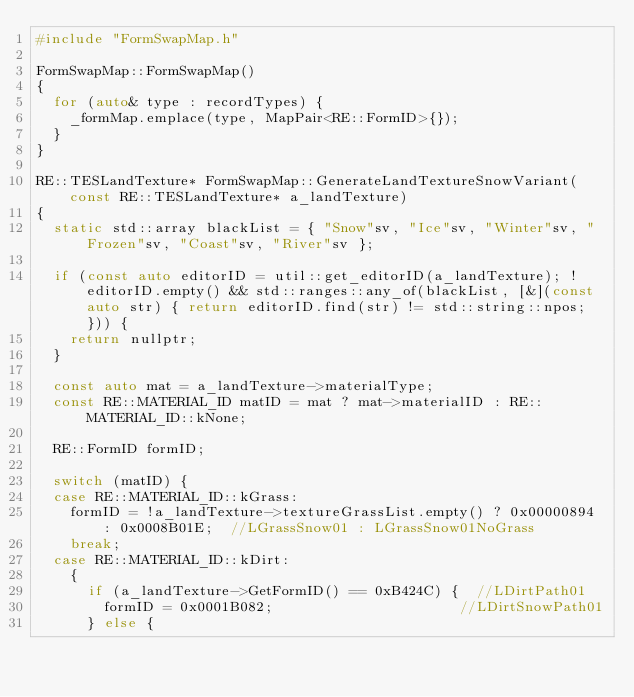<code> <loc_0><loc_0><loc_500><loc_500><_C++_>#include "FormSwapMap.h"

FormSwapMap::FormSwapMap()
{
	for (auto& type : recordTypes) {
		_formMap.emplace(type, MapPair<RE::FormID>{});
	}
}

RE::TESLandTexture* FormSwapMap::GenerateLandTextureSnowVariant(const RE::TESLandTexture* a_landTexture)
{
	static std::array blackList = { "Snow"sv, "Ice"sv, "Winter"sv, "Frozen"sv, "Coast"sv, "River"sv };

	if (const auto editorID = util::get_editorID(a_landTexture); !editorID.empty() && std::ranges::any_of(blackList, [&](const auto str) { return editorID.find(str) != std::string::npos; })) {
		return nullptr;
	}

	const auto mat = a_landTexture->materialType;
	const RE::MATERIAL_ID matID = mat ? mat->materialID : RE::MATERIAL_ID::kNone;

	RE::FormID formID;

	switch (matID) {
	case RE::MATERIAL_ID::kGrass:
		formID = !a_landTexture->textureGrassList.empty() ? 0x00000894 : 0x0008B01E;  //LGrassSnow01 : LGrassSnow01NoGrass
		break;
	case RE::MATERIAL_ID::kDirt:
		{
			if (a_landTexture->GetFormID() == 0xB424C) {  //LDirtPath01
				formID = 0x0001B082;                      //LDirtSnowPath01
			} else {</code> 